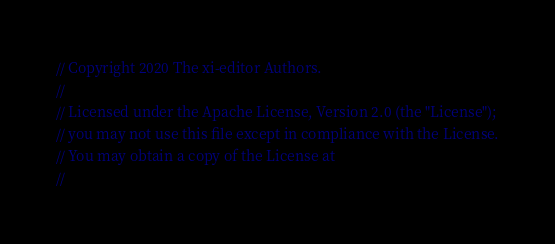<code> <loc_0><loc_0><loc_500><loc_500><_Rust_>// Copyright 2020 The xi-editor Authors.
//
// Licensed under the Apache License, Version 2.0 (the "License");
// you may not use this file except in compliance with the License.
// You may obtain a copy of the License at
//</code> 